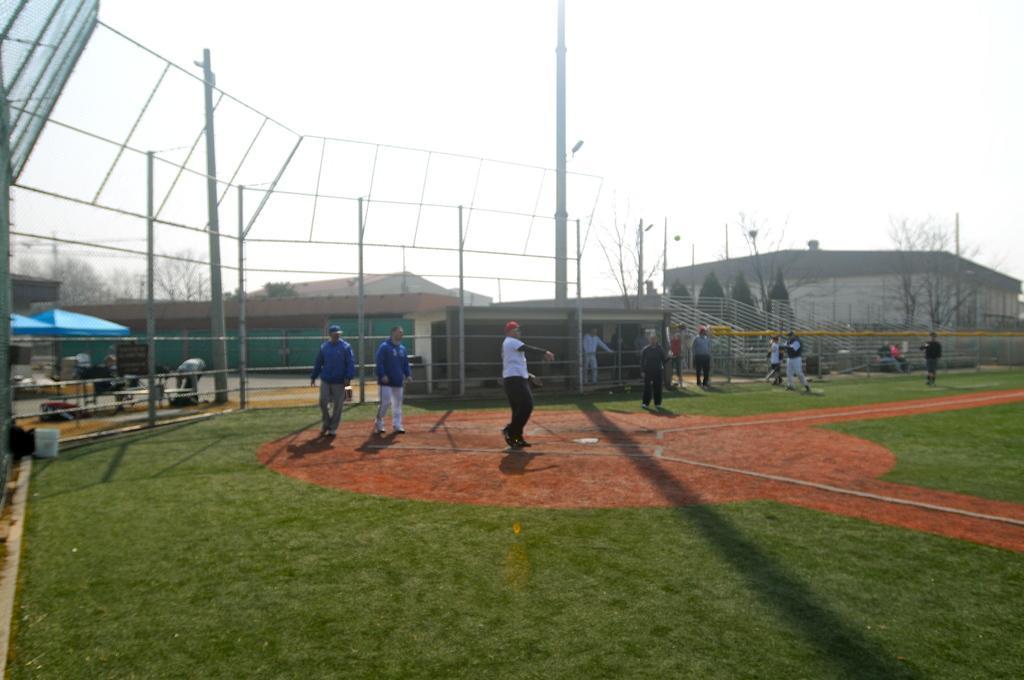Describe this image in one or two sentences. In this image there are group of people standing on the path and playing a game , and in the background there are umbrellas with poles, trees, buildings, chairs, tables, sky. 